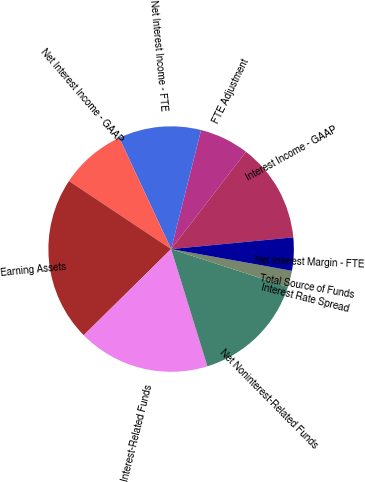Convert chart. <chart><loc_0><loc_0><loc_500><loc_500><pie_chart><fcel>Interest Income - GAAP<fcel>FTE Adjustment<fcel>Net Interest Income - FTE<fcel>Net Interest Income - GAAP<fcel>Earning Assets<fcel>Interest-Related Funds<fcel>Net Noninterest-Related Funds<fcel>Interest Rate Spread<fcel>Total Source of Funds<fcel>Net Interest Margin - FTE<nl><fcel>13.04%<fcel>6.52%<fcel>10.87%<fcel>8.7%<fcel>21.74%<fcel>17.39%<fcel>15.22%<fcel>2.17%<fcel>0.0%<fcel>4.35%<nl></chart> 